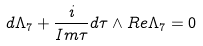<formula> <loc_0><loc_0><loc_500><loc_500>d \Lambda _ { 7 } + \frac { i } { I m \tau } d \tau \wedge R e \Lambda _ { 7 } = 0</formula> 